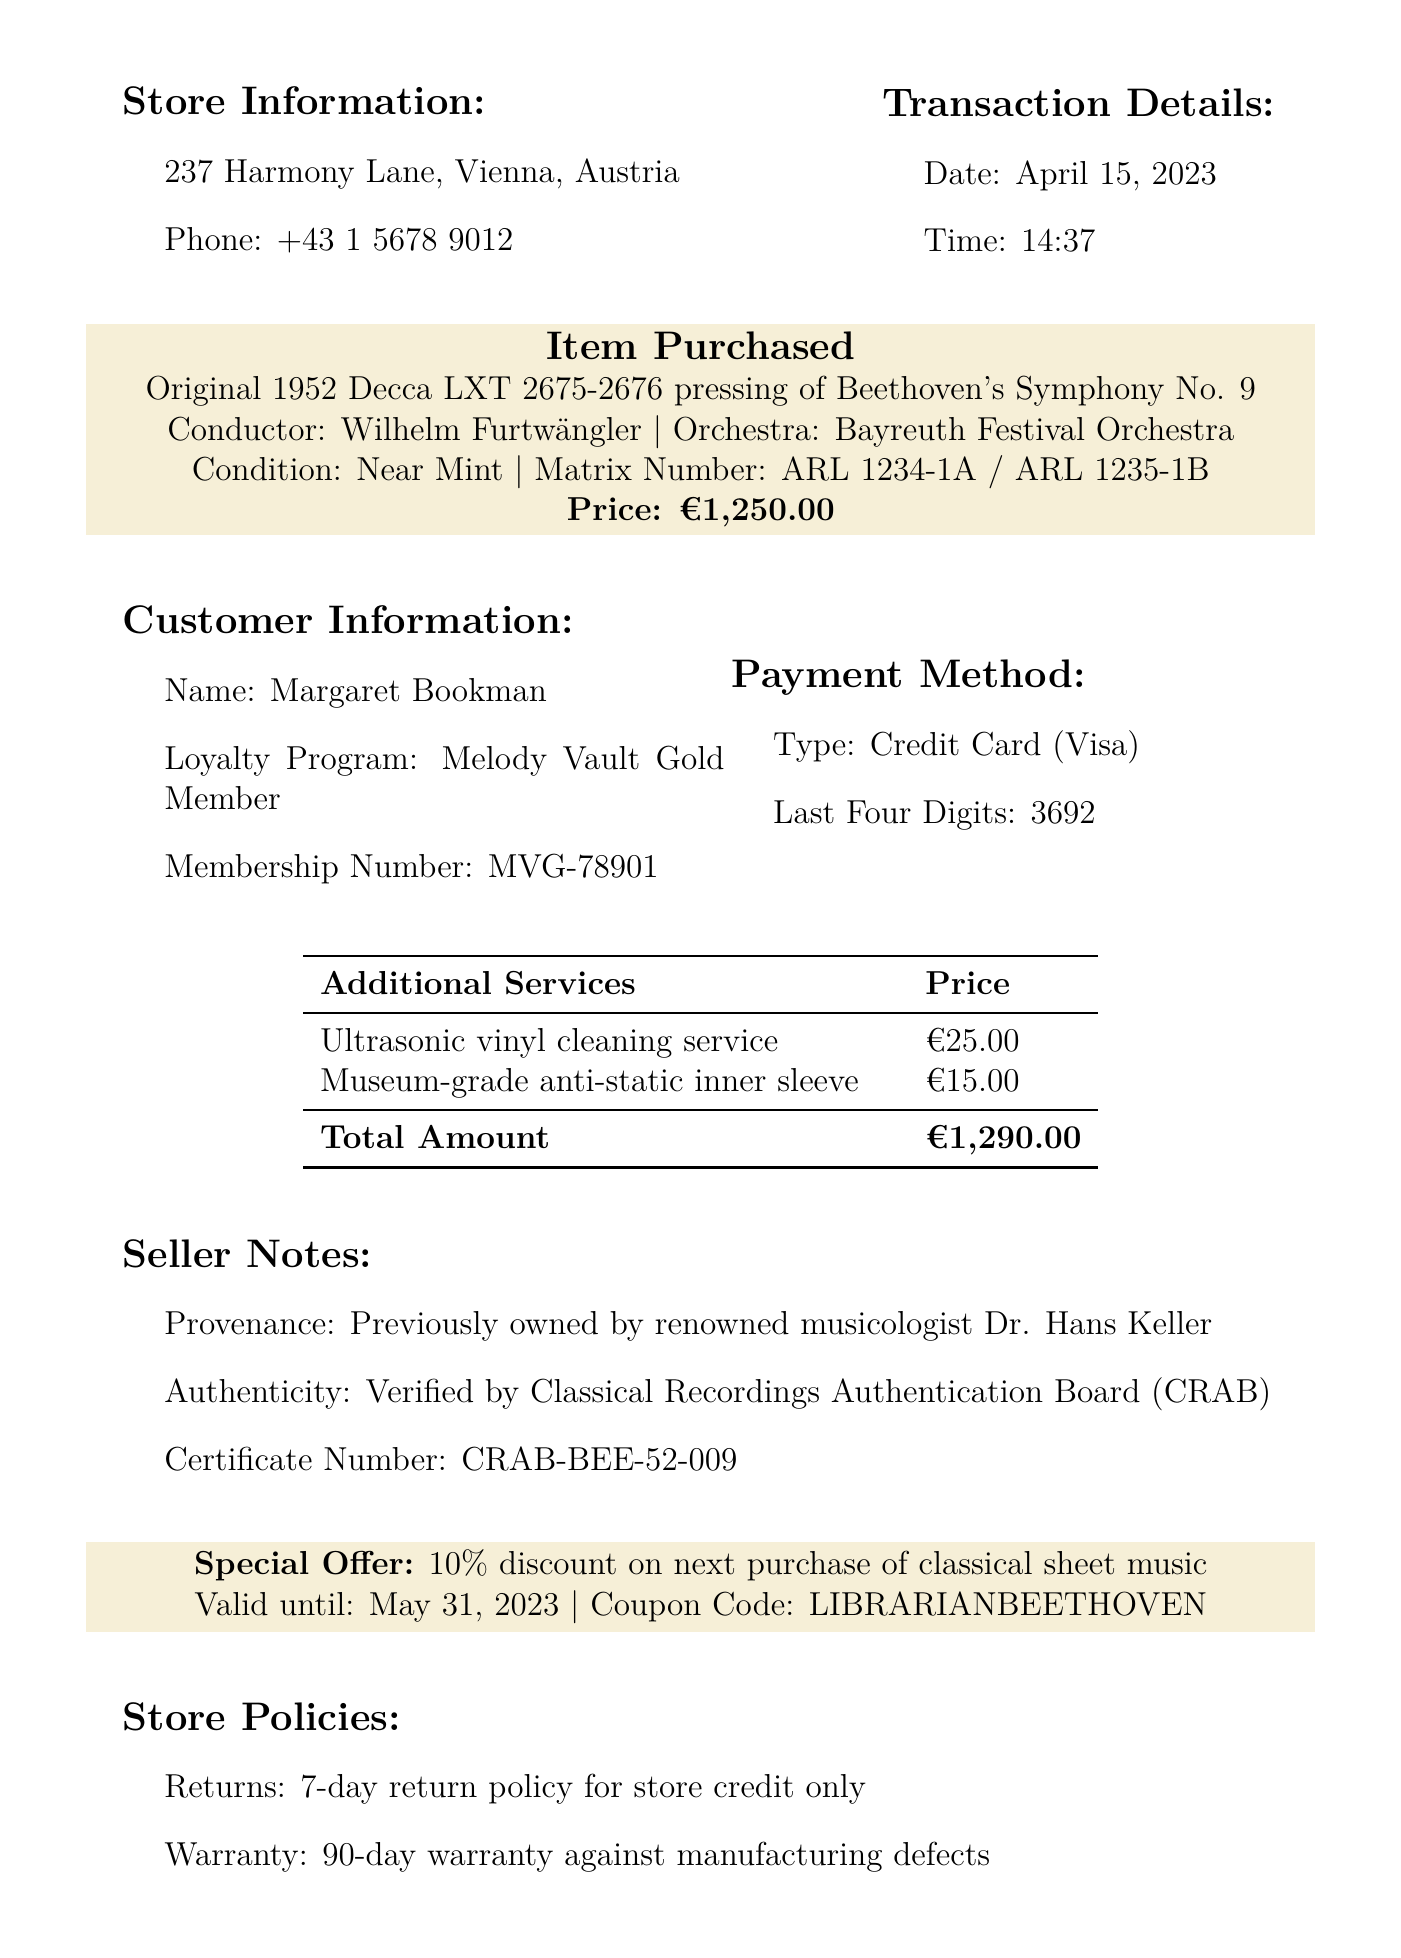What is the store name? The store name is specified at the top of the document and identifies where the transaction took place.
Answer: Melody Vault Antiques What is the date of the transaction? The date of the transaction is provided in the document under the transaction details section.
Answer: April 15, 2023 Who conducted the symphony? The document mentions the conductor responsible for the performance of the item purchased.
Answer: Wilhelm Furtwängler What is the price of the buying item? The price is explicitly listed in the item purchased section of the document.
Answer: €1,250.00 What is the total amount payable? The total amount is the sum of the item price and any additional services as detailed in the document.
Answer: €1,290.00 What is the membership number of the customer? The membership number is provided in the customer information section of the document.
Answer: MVG-78901 What type of vinyl cleaning service is offered? The additional services section of the document describes the cleaning service available for purchase.
Answer: Ultrasonic vinyl cleaning service What discount is offered for the next purchase? The special offers section outlines the terms for the discount given with the document.
Answer: 10% discount How long is the return policy valid for? The store policies section explains the duration of the return policy listed in the document.
Answer: 7-day return policy 